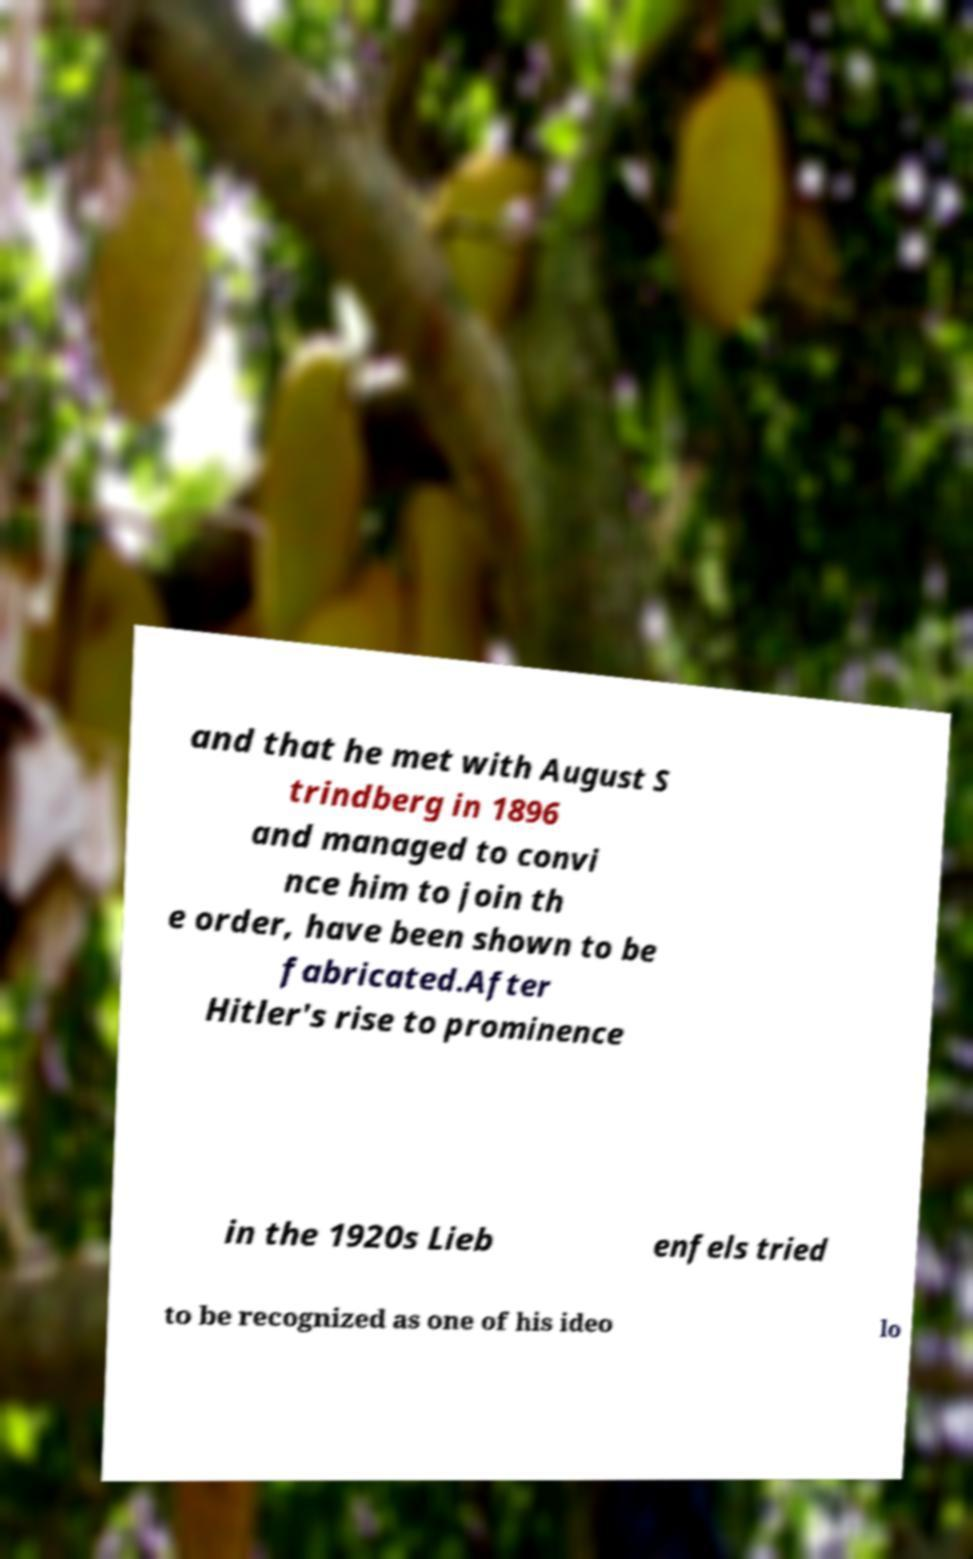Please read and relay the text visible in this image. What does it say? and that he met with August S trindberg in 1896 and managed to convi nce him to join th e order, have been shown to be fabricated.After Hitler's rise to prominence in the 1920s Lieb enfels tried to be recognized as one of his ideo lo 